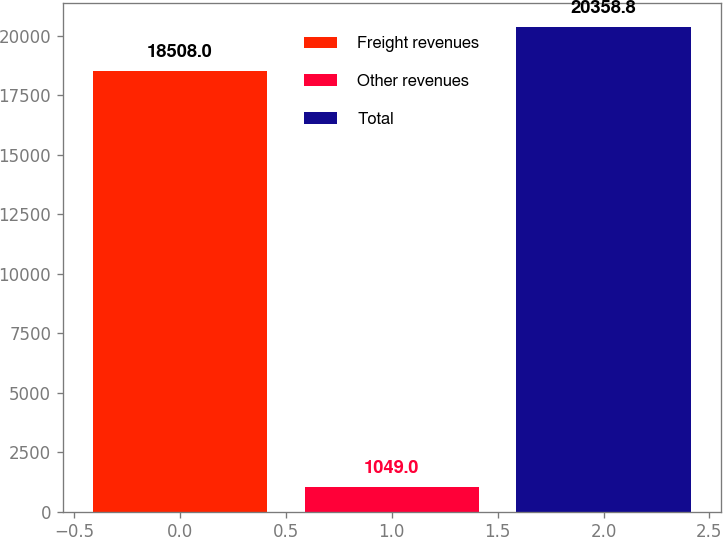Convert chart to OTSL. <chart><loc_0><loc_0><loc_500><loc_500><bar_chart><fcel>Freight revenues<fcel>Other revenues<fcel>Total<nl><fcel>18508<fcel>1049<fcel>20358.8<nl></chart> 